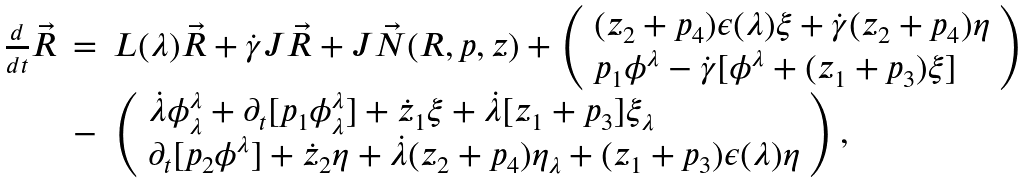Convert formula to latex. <formula><loc_0><loc_0><loc_500><loc_500>\begin{array} { l l l } \frac { d } { d t } \vec { R } & = & L ( \lambda ) \vec { R } + \dot { \gamma } J \vec { R } + J \vec { N } ( R , p , z ) + \left ( \begin{array} { l l l } ( z _ { 2 } + p _ { 4 } ) \epsilon ( \lambda ) \xi + \dot { \gamma } ( z _ { 2 } + p _ { 4 } ) \eta \\ p _ { 1 } \phi ^ { \lambda } - \dot { \gamma } [ \phi ^ { \lambda } + ( z _ { 1 } + p _ { 3 } ) \xi ] \end{array} \right ) \\ & - & \left ( \begin{array} { l l l } \dot { \lambda } \phi _ { \lambda } ^ { \lambda } + \partial _ { t } [ p _ { 1 } \phi _ { \lambda } ^ { \lambda } ] + \dot { z } _ { 1 } \xi + \dot { \lambda } [ z _ { 1 } + p _ { 3 } ] \xi _ { \lambda } \\ \partial _ { t } [ p _ { 2 } \phi ^ { \lambda } ] + \dot { z } _ { 2 } \eta + \dot { \lambda } ( z _ { 2 } + p _ { 4 } ) \eta _ { \lambda } + ( z _ { 1 } + p _ { 3 } ) \epsilon ( \lambda ) \eta \end{array} \right ) , \end{array}</formula> 